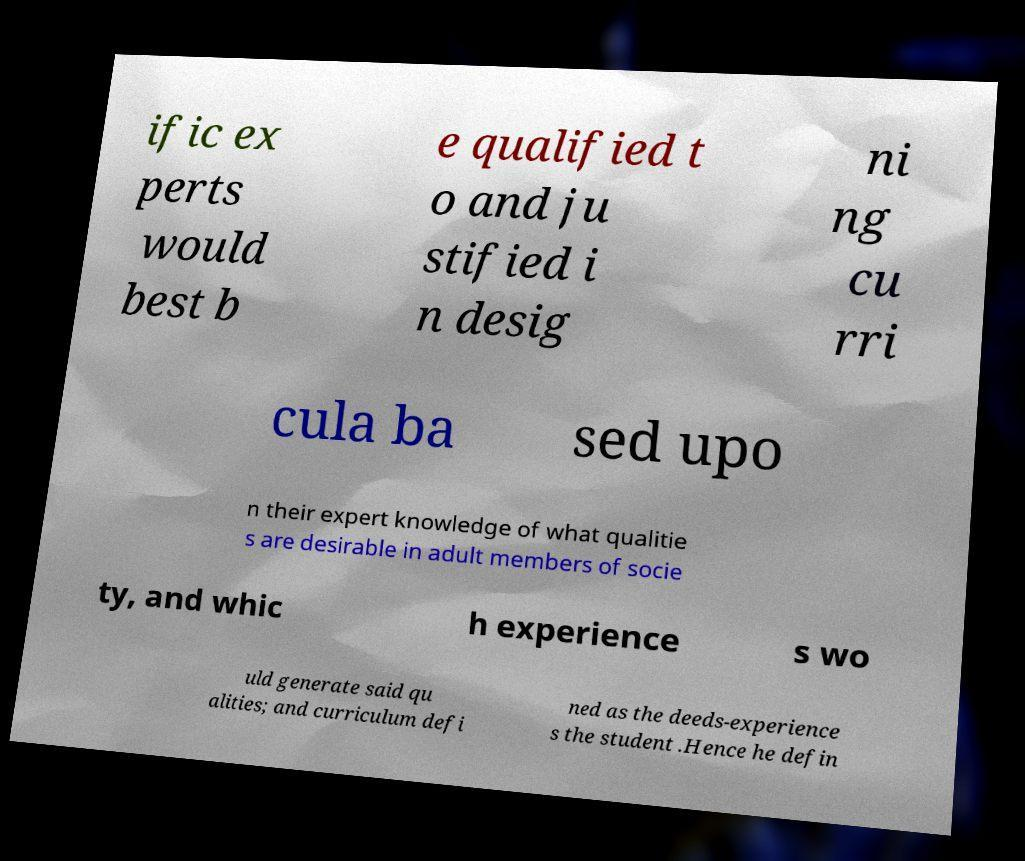Can you read and provide the text displayed in the image?This photo seems to have some interesting text. Can you extract and type it out for me? ific ex perts would best b e qualified t o and ju stified i n desig ni ng cu rri cula ba sed upo n their expert knowledge of what qualitie s are desirable in adult members of socie ty, and whic h experience s wo uld generate said qu alities; and curriculum defi ned as the deeds-experience s the student .Hence he defin 